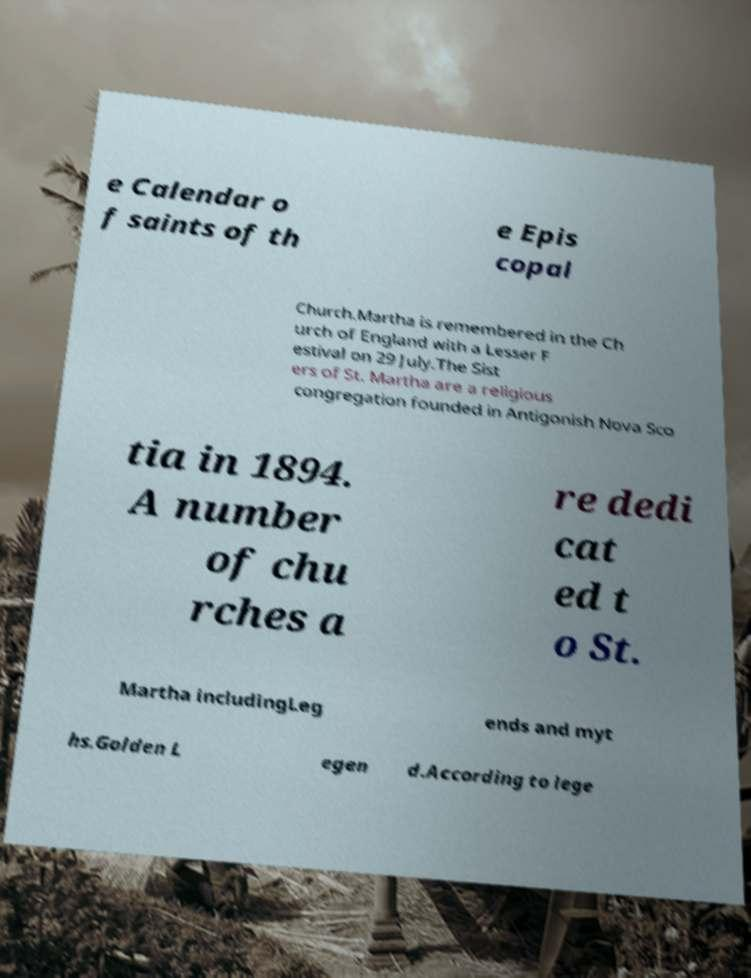For documentation purposes, I need the text within this image transcribed. Could you provide that? e Calendar o f saints of th e Epis copal Church.Martha is remembered in the Ch urch of England with a Lesser F estival on 29 July.The Sist ers of St. Martha are a religious congregation founded in Antigonish Nova Sco tia in 1894. A number of chu rches a re dedi cat ed t o St. Martha includingLeg ends and myt hs.Golden L egen d.According to lege 